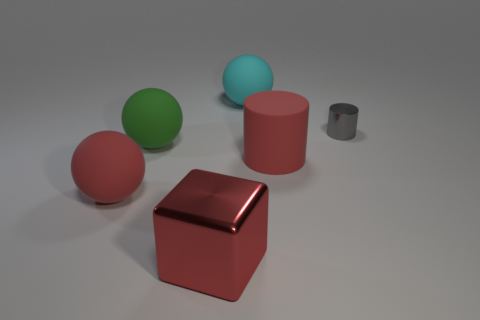Add 3 large blue shiny cylinders. How many objects exist? 9 Subtract all cubes. How many objects are left? 5 Subtract 0 brown blocks. How many objects are left? 6 Subtract all red matte balls. Subtract all large red cylinders. How many objects are left? 4 Add 5 cylinders. How many cylinders are left? 7 Add 5 big gray rubber cubes. How many big gray rubber cubes exist? 5 